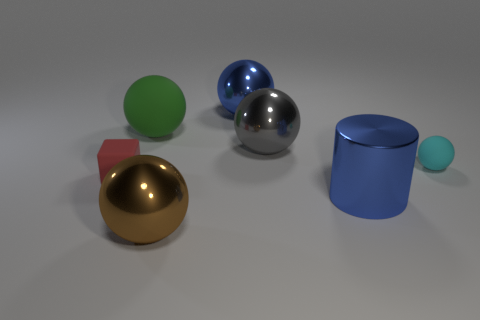Add 3 tiny spheres. How many tiny spheres exist? 4 Add 3 small cyan shiny cylinders. How many objects exist? 10 Subtract all cyan balls. How many balls are left? 4 Subtract all large green rubber balls. How many balls are left? 4 Subtract 1 blue cylinders. How many objects are left? 6 Subtract all blocks. How many objects are left? 6 Subtract 2 balls. How many balls are left? 3 Subtract all yellow blocks. Subtract all blue spheres. How many blocks are left? 1 Subtract all cyan blocks. How many cyan spheres are left? 1 Subtract all tiny blue rubber cubes. Subtract all large shiny spheres. How many objects are left? 4 